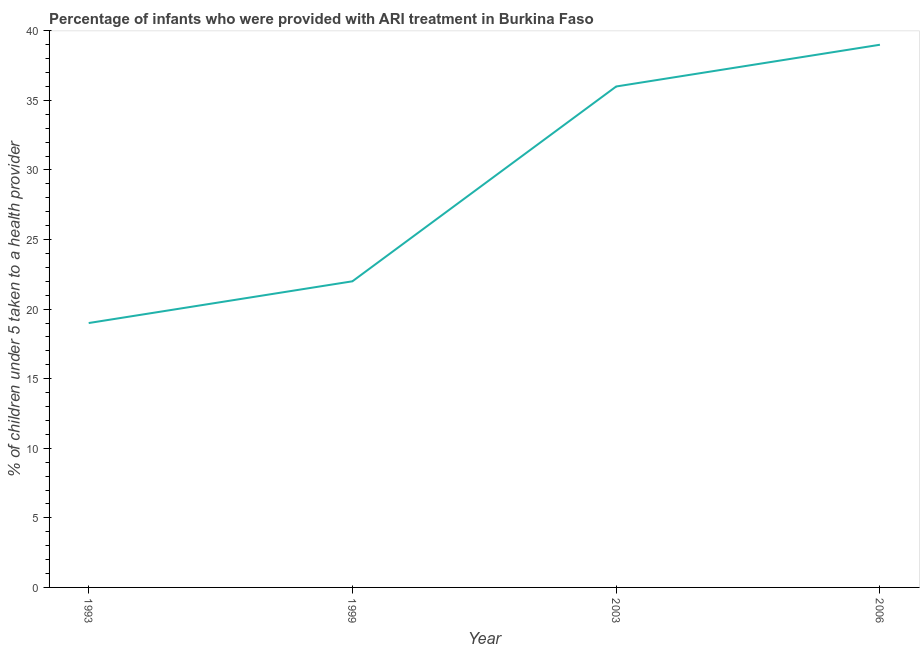What is the percentage of children who were provided with ari treatment in 1993?
Make the answer very short. 19. Across all years, what is the maximum percentage of children who were provided with ari treatment?
Offer a very short reply. 39. Across all years, what is the minimum percentage of children who were provided with ari treatment?
Your answer should be compact. 19. What is the sum of the percentage of children who were provided with ari treatment?
Provide a short and direct response. 116. What is the difference between the percentage of children who were provided with ari treatment in 1993 and 1999?
Your answer should be very brief. -3. What is the average percentage of children who were provided with ari treatment per year?
Your answer should be very brief. 29. What is the median percentage of children who were provided with ari treatment?
Ensure brevity in your answer.  29. Do a majority of the years between 1999 and 1993 (inclusive) have percentage of children who were provided with ari treatment greater than 23 %?
Make the answer very short. No. What is the ratio of the percentage of children who were provided with ari treatment in 1993 to that in 2003?
Ensure brevity in your answer.  0.53. Is the percentage of children who were provided with ari treatment in 1999 less than that in 2003?
Provide a short and direct response. Yes. What is the difference between the highest and the lowest percentage of children who were provided with ari treatment?
Make the answer very short. 20. How many lines are there?
Offer a very short reply. 1. How many years are there in the graph?
Give a very brief answer. 4. What is the difference between two consecutive major ticks on the Y-axis?
Make the answer very short. 5. Does the graph contain grids?
Give a very brief answer. No. What is the title of the graph?
Provide a succinct answer. Percentage of infants who were provided with ARI treatment in Burkina Faso. What is the label or title of the Y-axis?
Your answer should be very brief. % of children under 5 taken to a health provider. What is the % of children under 5 taken to a health provider in 1993?
Give a very brief answer. 19. What is the % of children under 5 taken to a health provider in 1999?
Your answer should be compact. 22. What is the difference between the % of children under 5 taken to a health provider in 1993 and 1999?
Make the answer very short. -3. What is the difference between the % of children under 5 taken to a health provider in 1993 and 2003?
Provide a succinct answer. -17. What is the difference between the % of children under 5 taken to a health provider in 1999 and 2003?
Make the answer very short. -14. What is the difference between the % of children under 5 taken to a health provider in 1999 and 2006?
Your answer should be compact. -17. What is the difference between the % of children under 5 taken to a health provider in 2003 and 2006?
Provide a short and direct response. -3. What is the ratio of the % of children under 5 taken to a health provider in 1993 to that in 1999?
Your answer should be compact. 0.86. What is the ratio of the % of children under 5 taken to a health provider in 1993 to that in 2003?
Give a very brief answer. 0.53. What is the ratio of the % of children under 5 taken to a health provider in 1993 to that in 2006?
Your response must be concise. 0.49. What is the ratio of the % of children under 5 taken to a health provider in 1999 to that in 2003?
Give a very brief answer. 0.61. What is the ratio of the % of children under 5 taken to a health provider in 1999 to that in 2006?
Offer a terse response. 0.56. What is the ratio of the % of children under 5 taken to a health provider in 2003 to that in 2006?
Give a very brief answer. 0.92. 